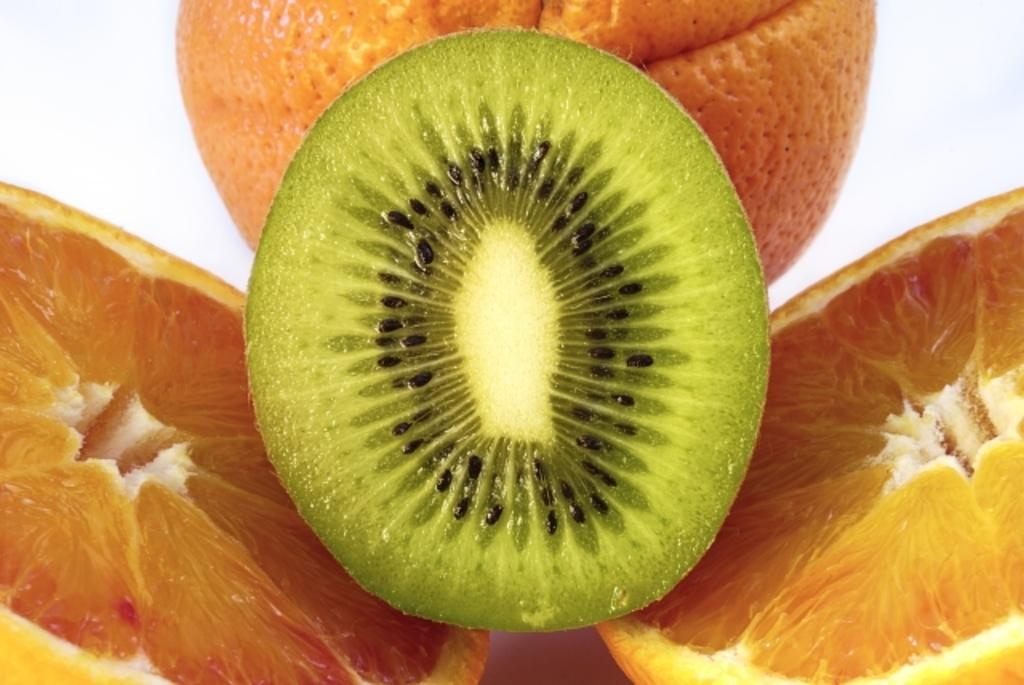What type of fruit is the main subject of the picture? There is an orange in the picture. How is the orange presented in the image? There are two halves of another orange in the picture. What other fruit can be seen in the image? There is a piece of kiwi fruit in the picture. How does the sky appear in the picture? There is no sky visible in the picture; it is focused on the fruits. What is the process of digestion for the fruits in the image? The image does not show the process of digestion for the fruits; it only depicts their appearance. 